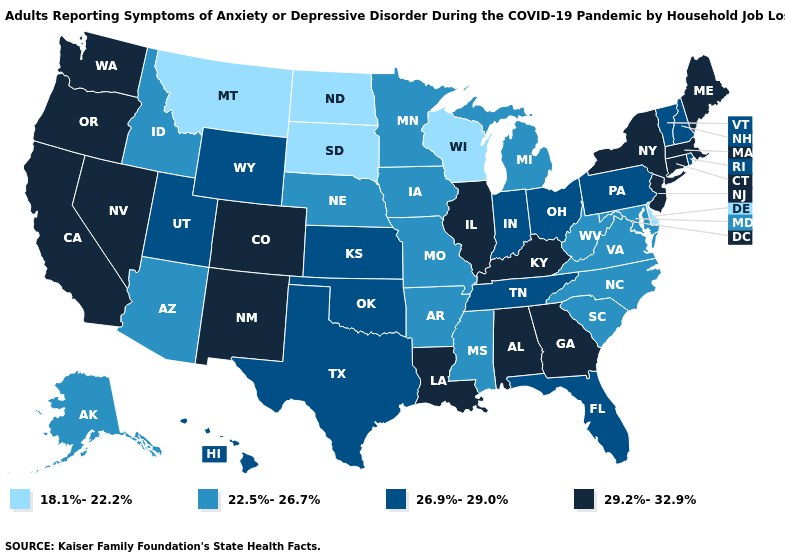What is the value of Kentucky?
Be succinct. 29.2%-32.9%. What is the value of Montana?
Give a very brief answer. 18.1%-22.2%. Which states have the lowest value in the South?
Write a very short answer. Delaware. Does Hawaii have a lower value than Tennessee?
Be succinct. No. Name the states that have a value in the range 18.1%-22.2%?
Answer briefly. Delaware, Montana, North Dakota, South Dakota, Wisconsin. Name the states that have a value in the range 26.9%-29.0%?
Quick response, please. Florida, Hawaii, Indiana, Kansas, New Hampshire, Ohio, Oklahoma, Pennsylvania, Rhode Island, Tennessee, Texas, Utah, Vermont, Wyoming. Name the states that have a value in the range 22.5%-26.7%?
Quick response, please. Alaska, Arizona, Arkansas, Idaho, Iowa, Maryland, Michigan, Minnesota, Mississippi, Missouri, Nebraska, North Carolina, South Carolina, Virginia, West Virginia. Does Washington have a higher value than Oklahoma?
Be succinct. Yes. What is the value of Alabama?
Keep it brief. 29.2%-32.9%. What is the lowest value in the USA?
Be succinct. 18.1%-22.2%. What is the value of North Carolina?
Quick response, please. 22.5%-26.7%. Does Delaware have a lower value than North Dakota?
Keep it brief. No. What is the value of North Carolina?
Short answer required. 22.5%-26.7%. Does North Carolina have a higher value than Massachusetts?
Keep it brief. No. Among the states that border Pennsylvania , which have the lowest value?
Quick response, please. Delaware. 